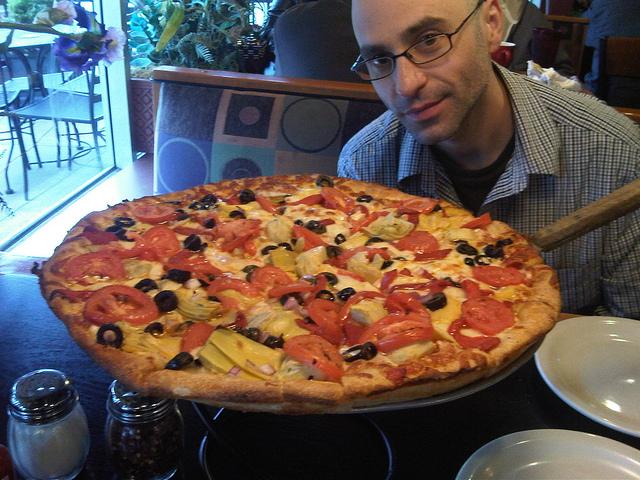What are 3 of the vegetables on the pizza?
Be succinct. Olives tomatoes artichokes. What is the pattern on the man's shirt?
Be succinct. Checkered. What type of cheese is found on the table?
Quick response, please. Parmesan. 